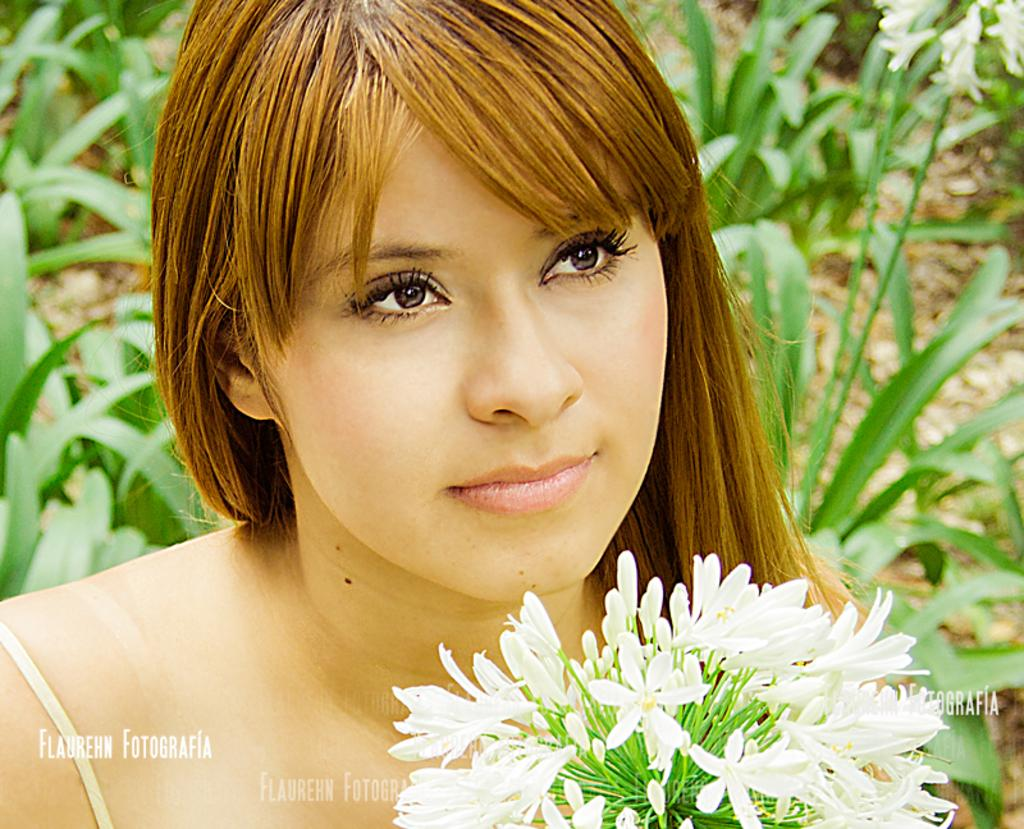Who is present in the image? There is a woman in the image. What type of flowers can be seen in the image? There are white-colored flowers in the image. What color are the plants in the background of the image? There are green-colored plants in the background of the image. What additional feature can be observed in the image? Watermarks are visible in the image. What type of silk fabric is being used to make the woman's dress in the image? There is no information about the material of the woman's dress in the image, so it cannot be determined if silk is being used. 